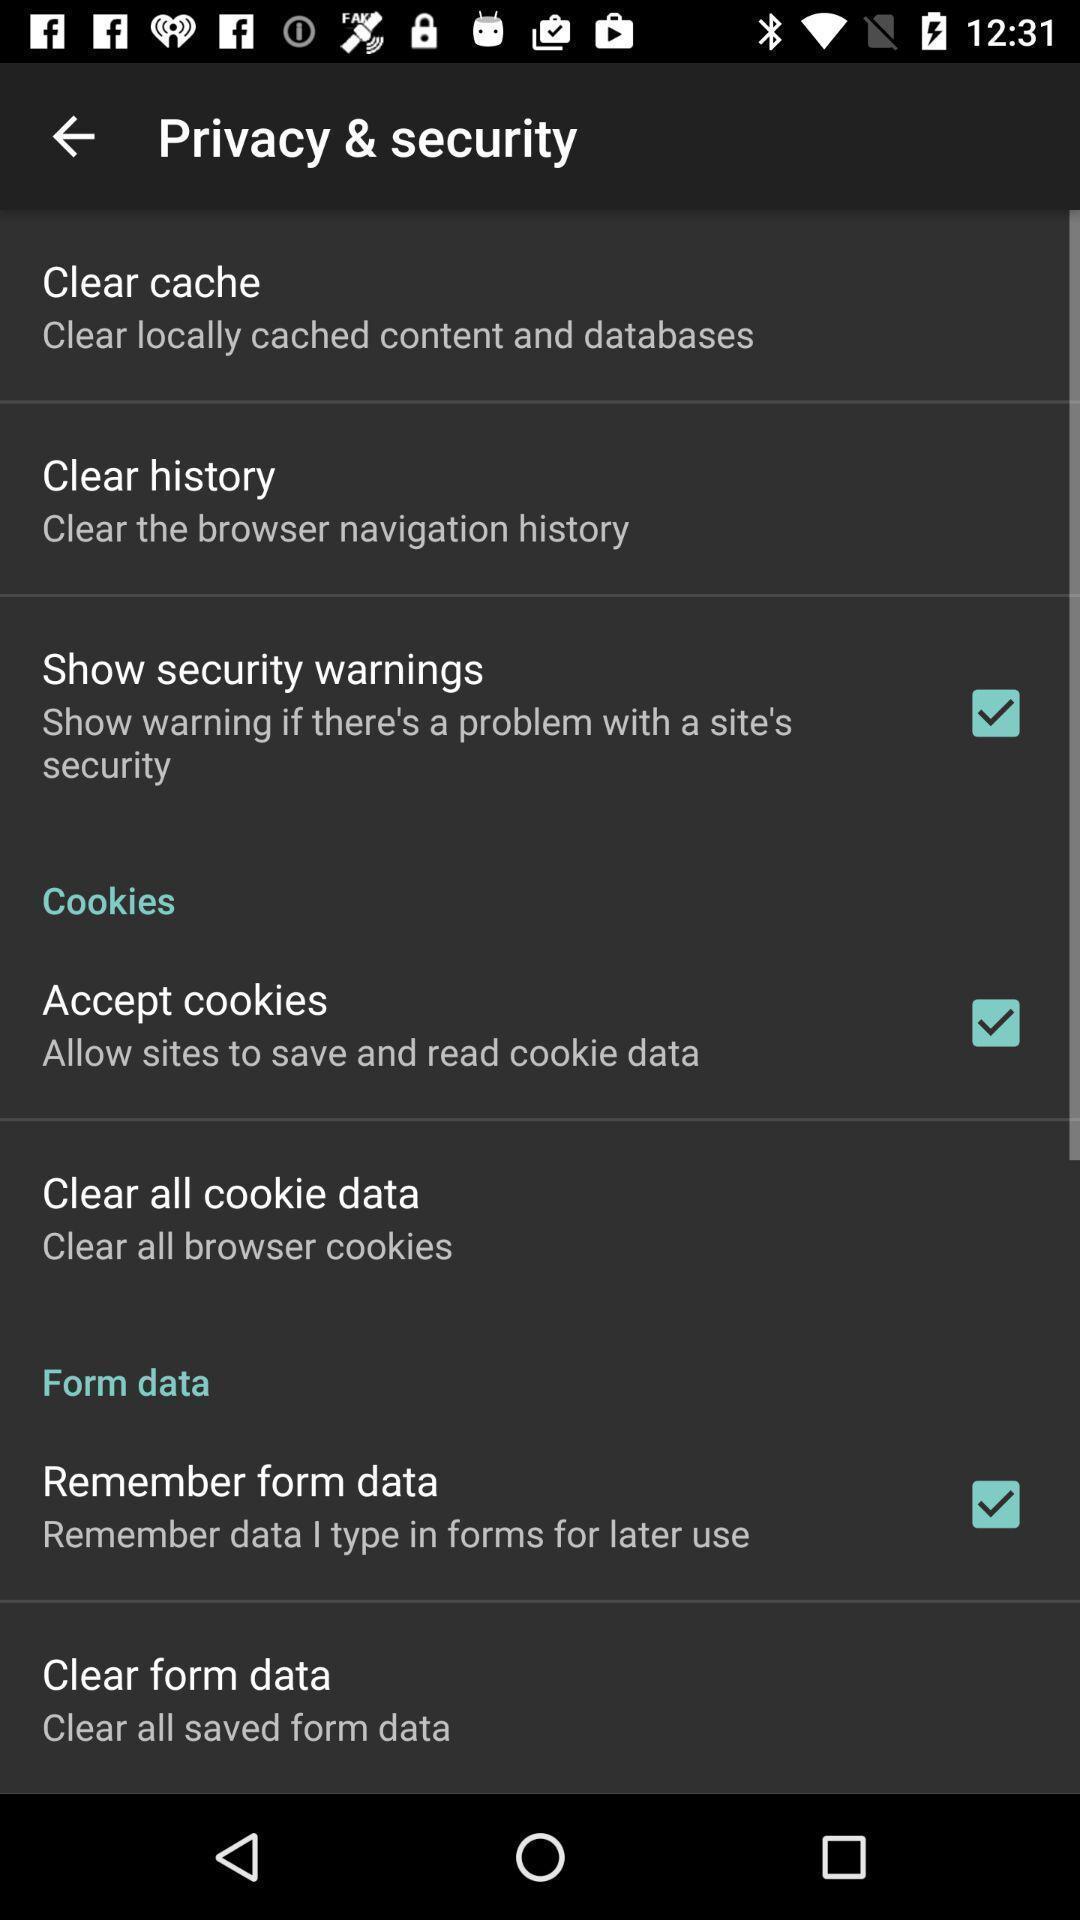Explain what's happening in this screen capture. Screen shows privacy and security page settings of financial app. 